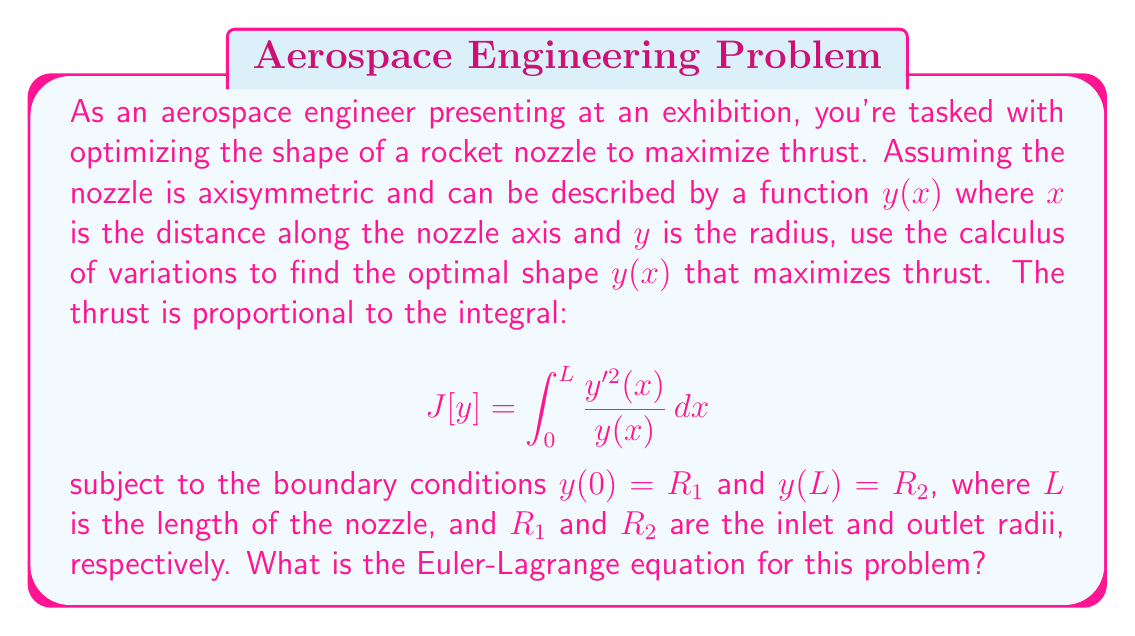Teach me how to tackle this problem. To solve this problem using variational calculus, we need to apply the Euler-Lagrange equation. The general form of the Euler-Lagrange equation is:

$$ \frac{\partial F}{\partial y} - \frac{d}{dx}\left(\frac{\partial F}{\partial y'}\right) = 0 $$

where $F(x,y,y')$ is the integrand of our functional $J[y]$.

In our case, $F(x,y,y') = \frac{y'^2}{y}$.

Let's calculate the partial derivatives:

1) $\frac{\partial F}{\partial y} = -\frac{y'^2}{y^2}$

2) $\frac{\partial F}{\partial y'} = \frac{2y'}{y}$

Now, we need to calculate $\frac{d}{dx}\left(\frac{\partial F}{\partial y'}\right)$:

$\frac{d}{dx}\left(\frac{2y'}{y}\right) = \frac{2y''y - 2y'^2}{y^2}$

Substituting these into the Euler-Lagrange equation:

$$ -\frac{y'^2}{y^2} - \frac{2y''y - 2y'^2}{y^2} = 0 $$

Simplifying:

$$ -y'^2 - 2y''y + 2y'^2 = 0 $$
$$ -2y''y + y'^2 = 0 $$
$$ 2y''y = y'^2 $$

This is the Euler-Lagrange equation for our problem.
Answer: The Euler-Lagrange equation for the optimal nozzle shape is:

$$ 2y''y = y'^2 $$

where $y = y(x)$ is the radius of the nozzle as a function of the axial distance $x$. 